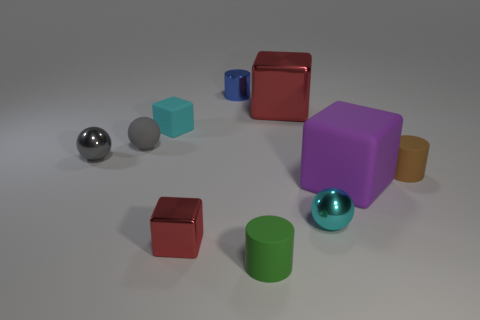There is another metal block that is the same color as the tiny shiny block; what size is it? large 